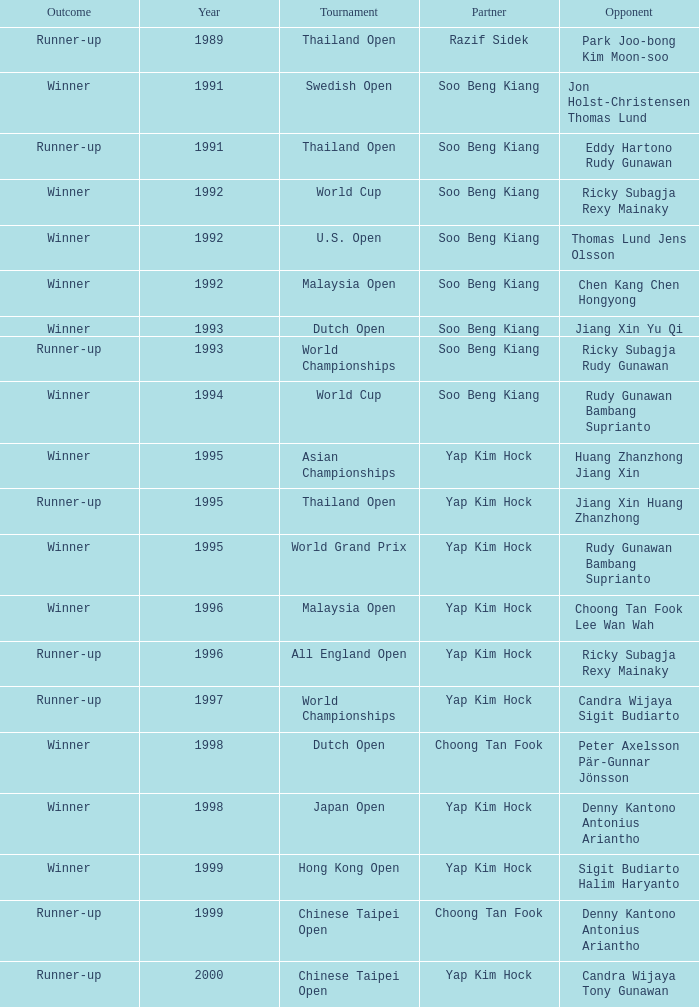Who was Choong Tan Fook's opponent in 1999? Denny Kantono Antonius Ariantho. Parse the full table. {'header': ['Outcome', 'Year', 'Tournament', 'Partner', 'Opponent'], 'rows': [['Runner-up', '1989', 'Thailand Open', 'Razif Sidek', 'Park Joo-bong Kim Moon-soo'], ['Winner', '1991', 'Swedish Open', 'Soo Beng Kiang', 'Jon Holst-Christensen Thomas Lund'], ['Runner-up', '1991', 'Thailand Open', 'Soo Beng Kiang', 'Eddy Hartono Rudy Gunawan'], ['Winner', '1992', 'World Cup', 'Soo Beng Kiang', 'Ricky Subagja Rexy Mainaky'], ['Winner', '1992', 'U.S. Open', 'Soo Beng Kiang', 'Thomas Lund Jens Olsson'], ['Winner', '1992', 'Malaysia Open', 'Soo Beng Kiang', 'Chen Kang Chen Hongyong'], ['Winner', '1993', 'Dutch Open', 'Soo Beng Kiang', 'Jiang Xin Yu Qi'], ['Runner-up', '1993', 'World Championships', 'Soo Beng Kiang', 'Ricky Subagja Rudy Gunawan'], ['Winner', '1994', 'World Cup', 'Soo Beng Kiang', 'Rudy Gunawan Bambang Suprianto'], ['Winner', '1995', 'Asian Championships', 'Yap Kim Hock', 'Huang Zhanzhong Jiang Xin'], ['Runner-up', '1995', 'Thailand Open', 'Yap Kim Hock', 'Jiang Xin Huang Zhanzhong'], ['Winner', '1995', 'World Grand Prix', 'Yap Kim Hock', 'Rudy Gunawan Bambang Suprianto'], ['Winner', '1996', 'Malaysia Open', 'Yap Kim Hock', 'Choong Tan Fook Lee Wan Wah'], ['Runner-up', '1996', 'All England Open', 'Yap Kim Hock', 'Ricky Subagja Rexy Mainaky'], ['Runner-up', '1997', 'World Championships', 'Yap Kim Hock', 'Candra Wijaya Sigit Budiarto'], ['Winner', '1998', 'Dutch Open', 'Choong Tan Fook', 'Peter Axelsson Pär-Gunnar Jönsson'], ['Winner', '1998', 'Japan Open', 'Yap Kim Hock', 'Denny Kantono Antonius Ariantho'], ['Winner', '1999', 'Hong Kong Open', 'Yap Kim Hock', 'Sigit Budiarto Halim Haryanto'], ['Runner-up', '1999', 'Chinese Taipei Open', 'Choong Tan Fook', 'Denny Kantono Antonius Ariantho'], ['Runner-up', '2000', 'Chinese Taipei Open', 'Yap Kim Hock', 'Candra Wijaya Tony Gunawan']]} 